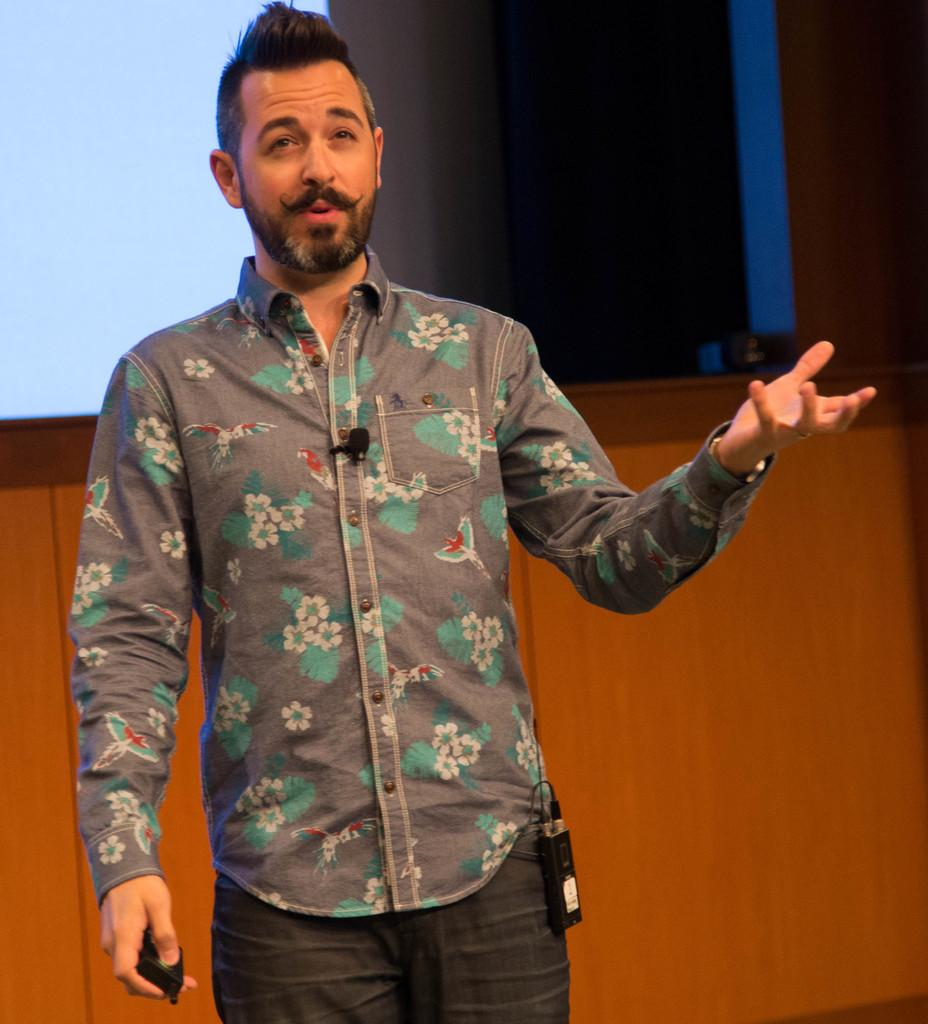What is the main subject in the foreground of the picture? There is a person standing in the foreground of the foreground of the picture. What can be seen on the person in the picture? The person is wearing a mic. What object is the person holding in the picture? The person is holding a remote. What can be seen in the background of the picture? There is a projector screen and a curtain in the background of the picture. What is located at the bottom of the image? There is a well at the bottom of the image. What type of plot is being discussed by the person holding the banana in the image? There is no banana present in the image, and therefore no discussion about a plot can be observed. What type of coach is visible in the background of the image? There is no coach present in the image. 